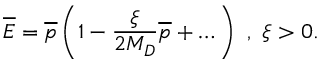<formula> <loc_0><loc_0><loc_500><loc_500>{ \overline { E } } = { \overline { p } } \left ( 1 - \frac { \xi } { 2 M _ { D } } { \overline { p } } + \dots \right ) , \xi > 0 .</formula> 